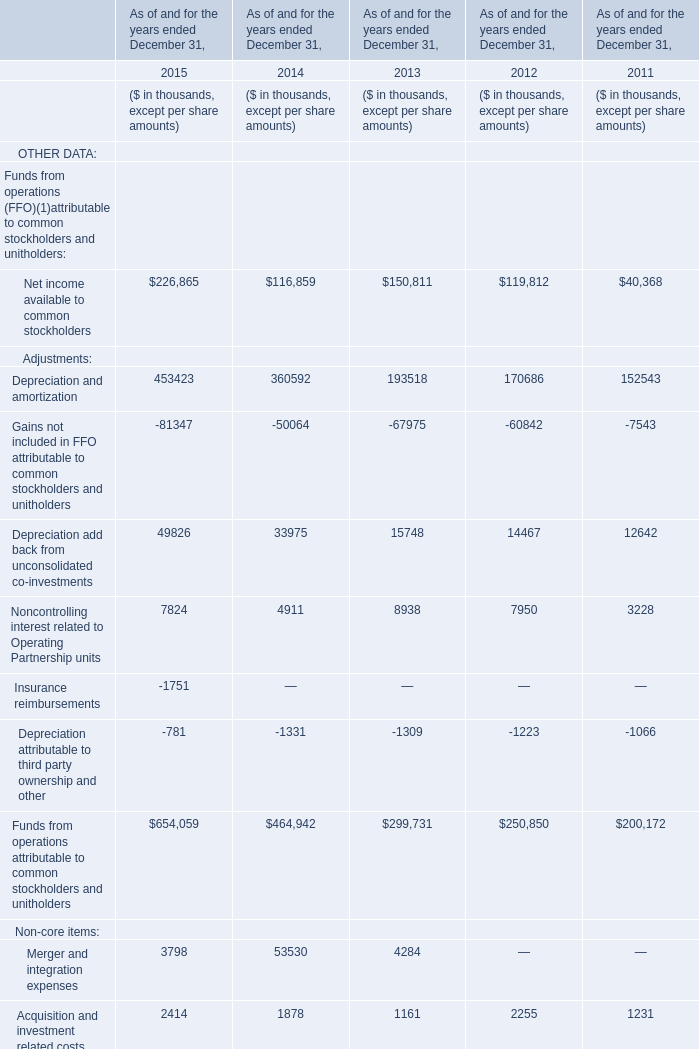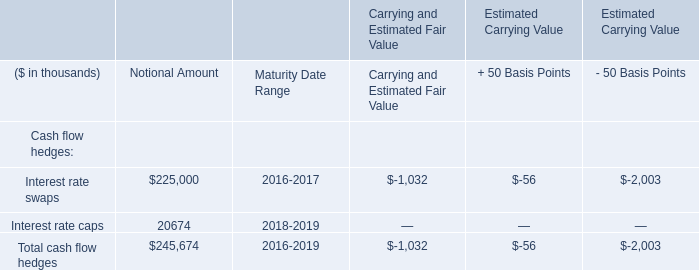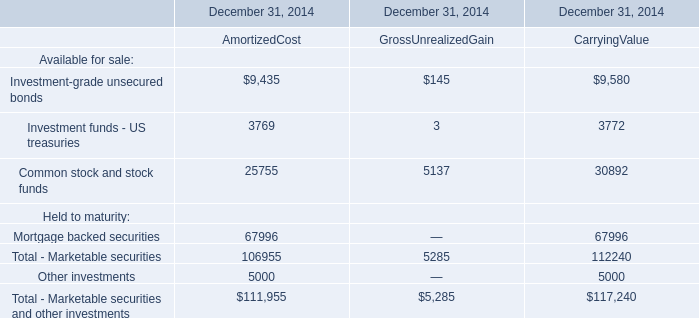What was the total amount of Core funds from operations (Core FFO) attributable to common stockholders and unitholders in 2011? (in $ in thousands) 
Answer: 196779. 